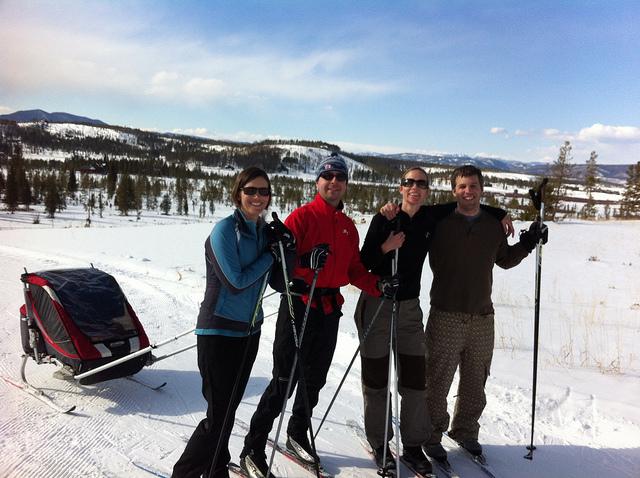Is this picture in color?
Give a very brief answer. Yes. Is it snowing?
Give a very brief answer. No. Do you think the couple could have found a warmer place to get a picture taken?
Give a very brief answer. Yes. What color is the sky?
Answer briefly. Blue. Do they expect to be gone for a while?
Concise answer only. Yes. Is it a sunny day?
Be succinct. Yes. Are both of the skiers wearing helmets?
Keep it brief. No. How many people are looking at the camera?
Quick response, please. 4. 